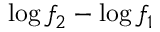<formula> <loc_0><loc_0><loc_500><loc_500>\log f _ { 2 } - \log f _ { 1 }</formula> 